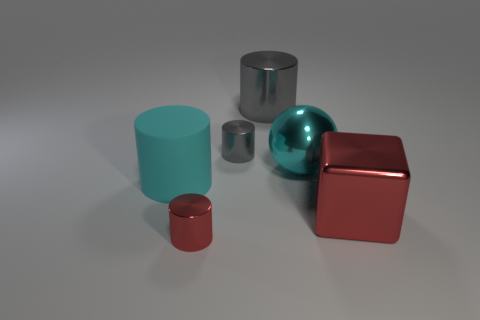Add 1 tiny purple matte cylinders. How many objects exist? 7 Subtract all yellow cylinders. Subtract all purple spheres. How many cylinders are left? 4 Subtract all cubes. How many objects are left? 5 Add 6 red things. How many red things exist? 8 Subtract 0 blue cylinders. How many objects are left? 6 Subtract all large gray shiny things. Subtract all metal balls. How many objects are left? 4 Add 1 large cyan things. How many large cyan things are left? 3 